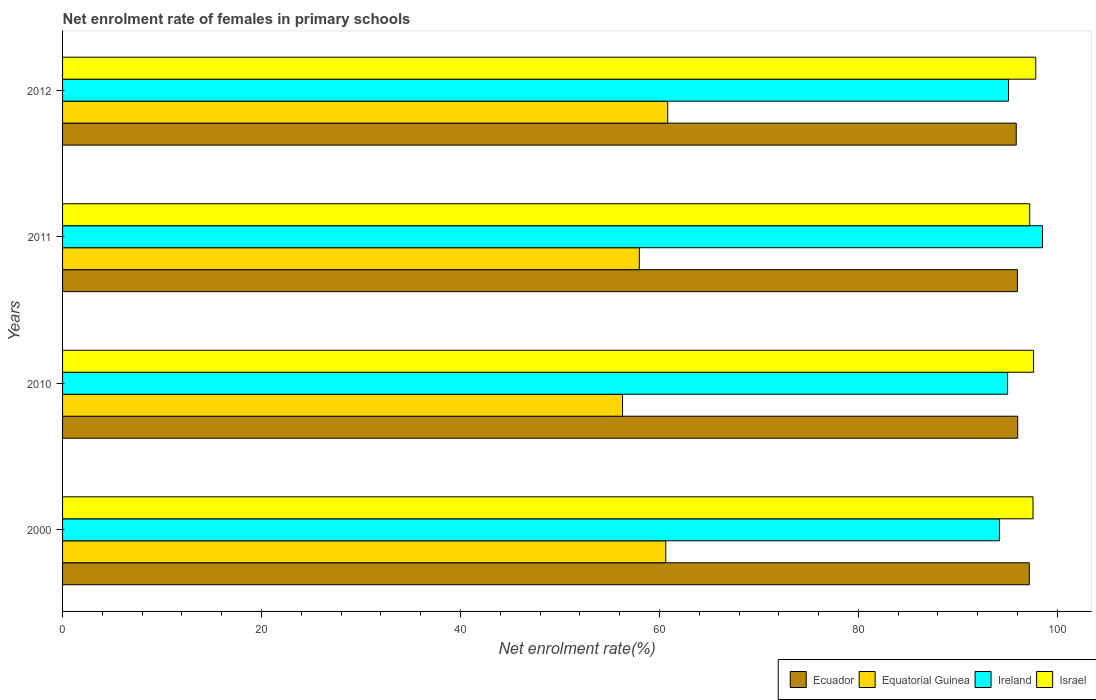How many different coloured bars are there?
Give a very brief answer. 4. Are the number of bars per tick equal to the number of legend labels?
Your answer should be very brief. Yes. How many bars are there on the 4th tick from the top?
Provide a short and direct response. 4. How many bars are there on the 4th tick from the bottom?
Your response must be concise. 4. In how many cases, is the number of bars for a given year not equal to the number of legend labels?
Your response must be concise. 0. What is the net enrolment rate of females in primary schools in Ecuador in 2000?
Provide a short and direct response. 97.18. Across all years, what is the maximum net enrolment rate of females in primary schools in Ireland?
Give a very brief answer. 98.51. Across all years, what is the minimum net enrolment rate of females in primary schools in Israel?
Offer a very short reply. 97.22. In which year was the net enrolment rate of females in primary schools in Equatorial Guinea maximum?
Your answer should be compact. 2012. What is the total net enrolment rate of females in primary schools in Equatorial Guinea in the graph?
Your answer should be very brief. 235.74. What is the difference between the net enrolment rate of females in primary schools in Israel in 2010 and that in 2011?
Keep it short and to the point. 0.39. What is the difference between the net enrolment rate of females in primary schools in Ireland in 2011 and the net enrolment rate of females in primary schools in Equatorial Guinea in 2000?
Your answer should be very brief. 37.87. What is the average net enrolment rate of females in primary schools in Equatorial Guinea per year?
Offer a terse response. 58.93. In the year 2011, what is the difference between the net enrolment rate of females in primary schools in Israel and net enrolment rate of females in primary schools in Ireland?
Offer a terse response. -1.28. In how many years, is the net enrolment rate of females in primary schools in Equatorial Guinea greater than 84 %?
Make the answer very short. 0. What is the ratio of the net enrolment rate of females in primary schools in Ecuador in 2000 to that in 2011?
Offer a terse response. 1.01. Is the net enrolment rate of females in primary schools in Israel in 2010 less than that in 2012?
Provide a succinct answer. Yes. Is the difference between the net enrolment rate of females in primary schools in Israel in 2000 and 2012 greater than the difference between the net enrolment rate of females in primary schools in Ireland in 2000 and 2012?
Provide a short and direct response. Yes. What is the difference between the highest and the second highest net enrolment rate of females in primary schools in Israel?
Make the answer very short. 0.22. What is the difference between the highest and the lowest net enrolment rate of females in primary schools in Israel?
Provide a short and direct response. 0.61. In how many years, is the net enrolment rate of females in primary schools in Equatorial Guinea greater than the average net enrolment rate of females in primary schools in Equatorial Guinea taken over all years?
Your answer should be compact. 2. Is the sum of the net enrolment rate of females in primary schools in Ireland in 2000 and 2010 greater than the maximum net enrolment rate of females in primary schools in Israel across all years?
Keep it short and to the point. Yes. What does the 2nd bar from the top in 2012 represents?
Ensure brevity in your answer.  Ireland. What does the 1st bar from the bottom in 2011 represents?
Offer a very short reply. Ecuador. Is it the case that in every year, the sum of the net enrolment rate of females in primary schools in Ireland and net enrolment rate of females in primary schools in Ecuador is greater than the net enrolment rate of females in primary schools in Equatorial Guinea?
Provide a succinct answer. Yes. How many bars are there?
Ensure brevity in your answer.  16. Does the graph contain grids?
Offer a terse response. No. Where does the legend appear in the graph?
Offer a terse response. Bottom right. What is the title of the graph?
Your answer should be very brief. Net enrolment rate of females in primary schools. Does "Indonesia" appear as one of the legend labels in the graph?
Your response must be concise. No. What is the label or title of the X-axis?
Your answer should be very brief. Net enrolment rate(%). What is the label or title of the Y-axis?
Keep it short and to the point. Years. What is the Net enrolment rate(%) of Ecuador in 2000?
Keep it short and to the point. 97.18. What is the Net enrolment rate(%) of Equatorial Guinea in 2000?
Offer a terse response. 60.64. What is the Net enrolment rate(%) in Ireland in 2000?
Your answer should be compact. 94.18. What is the Net enrolment rate(%) in Israel in 2000?
Your answer should be compact. 97.55. What is the Net enrolment rate(%) of Ecuador in 2010?
Your answer should be compact. 96.01. What is the Net enrolment rate(%) in Equatorial Guinea in 2010?
Ensure brevity in your answer.  56.29. What is the Net enrolment rate(%) in Ireland in 2010?
Offer a very short reply. 95. What is the Net enrolment rate(%) of Israel in 2010?
Your response must be concise. 97.61. What is the Net enrolment rate(%) in Ecuador in 2011?
Give a very brief answer. 95.98. What is the Net enrolment rate(%) of Equatorial Guinea in 2011?
Your answer should be very brief. 57.98. What is the Net enrolment rate(%) of Ireland in 2011?
Provide a succinct answer. 98.51. What is the Net enrolment rate(%) in Israel in 2011?
Offer a terse response. 97.22. What is the Net enrolment rate(%) of Ecuador in 2012?
Make the answer very short. 95.87. What is the Net enrolment rate(%) of Equatorial Guinea in 2012?
Your answer should be very brief. 60.83. What is the Net enrolment rate(%) of Ireland in 2012?
Keep it short and to the point. 95.09. What is the Net enrolment rate(%) of Israel in 2012?
Ensure brevity in your answer.  97.83. Across all years, what is the maximum Net enrolment rate(%) of Ecuador?
Provide a succinct answer. 97.18. Across all years, what is the maximum Net enrolment rate(%) in Equatorial Guinea?
Your answer should be very brief. 60.83. Across all years, what is the maximum Net enrolment rate(%) in Ireland?
Your answer should be compact. 98.51. Across all years, what is the maximum Net enrolment rate(%) of Israel?
Keep it short and to the point. 97.83. Across all years, what is the minimum Net enrolment rate(%) of Ecuador?
Your answer should be compact. 95.87. Across all years, what is the minimum Net enrolment rate(%) in Equatorial Guinea?
Offer a terse response. 56.29. Across all years, what is the minimum Net enrolment rate(%) of Ireland?
Provide a short and direct response. 94.18. Across all years, what is the minimum Net enrolment rate(%) in Israel?
Make the answer very short. 97.22. What is the total Net enrolment rate(%) in Ecuador in the graph?
Provide a succinct answer. 385.04. What is the total Net enrolment rate(%) in Equatorial Guinea in the graph?
Ensure brevity in your answer.  235.74. What is the total Net enrolment rate(%) in Ireland in the graph?
Provide a short and direct response. 382.77. What is the total Net enrolment rate(%) in Israel in the graph?
Provide a short and direct response. 390.21. What is the difference between the Net enrolment rate(%) in Ecuador in 2000 and that in 2010?
Give a very brief answer. 1.16. What is the difference between the Net enrolment rate(%) in Equatorial Guinea in 2000 and that in 2010?
Provide a short and direct response. 4.35. What is the difference between the Net enrolment rate(%) of Ireland in 2000 and that in 2010?
Offer a terse response. -0.82. What is the difference between the Net enrolment rate(%) in Israel in 2000 and that in 2010?
Offer a terse response. -0.05. What is the difference between the Net enrolment rate(%) of Ecuador in 2000 and that in 2011?
Offer a very short reply. 1.19. What is the difference between the Net enrolment rate(%) of Equatorial Guinea in 2000 and that in 2011?
Make the answer very short. 2.66. What is the difference between the Net enrolment rate(%) of Ireland in 2000 and that in 2011?
Your answer should be very brief. -4.33. What is the difference between the Net enrolment rate(%) of Israel in 2000 and that in 2011?
Your answer should be compact. 0.33. What is the difference between the Net enrolment rate(%) of Ecuador in 2000 and that in 2012?
Make the answer very short. 1.31. What is the difference between the Net enrolment rate(%) in Equatorial Guinea in 2000 and that in 2012?
Your answer should be very brief. -0.19. What is the difference between the Net enrolment rate(%) in Ireland in 2000 and that in 2012?
Give a very brief answer. -0.91. What is the difference between the Net enrolment rate(%) in Israel in 2000 and that in 2012?
Keep it short and to the point. -0.28. What is the difference between the Net enrolment rate(%) in Ecuador in 2010 and that in 2011?
Your response must be concise. 0.03. What is the difference between the Net enrolment rate(%) in Equatorial Guinea in 2010 and that in 2011?
Offer a very short reply. -1.69. What is the difference between the Net enrolment rate(%) of Ireland in 2010 and that in 2011?
Provide a succinct answer. -3.51. What is the difference between the Net enrolment rate(%) in Israel in 2010 and that in 2011?
Keep it short and to the point. 0.39. What is the difference between the Net enrolment rate(%) in Ecuador in 2010 and that in 2012?
Your response must be concise. 0.15. What is the difference between the Net enrolment rate(%) of Equatorial Guinea in 2010 and that in 2012?
Provide a succinct answer. -4.54. What is the difference between the Net enrolment rate(%) of Ireland in 2010 and that in 2012?
Give a very brief answer. -0.09. What is the difference between the Net enrolment rate(%) of Israel in 2010 and that in 2012?
Your response must be concise. -0.22. What is the difference between the Net enrolment rate(%) in Ecuador in 2011 and that in 2012?
Your answer should be compact. 0.12. What is the difference between the Net enrolment rate(%) of Equatorial Guinea in 2011 and that in 2012?
Keep it short and to the point. -2.85. What is the difference between the Net enrolment rate(%) in Ireland in 2011 and that in 2012?
Your answer should be compact. 3.41. What is the difference between the Net enrolment rate(%) of Israel in 2011 and that in 2012?
Ensure brevity in your answer.  -0.61. What is the difference between the Net enrolment rate(%) of Ecuador in 2000 and the Net enrolment rate(%) of Equatorial Guinea in 2010?
Make the answer very short. 40.88. What is the difference between the Net enrolment rate(%) in Ecuador in 2000 and the Net enrolment rate(%) in Ireland in 2010?
Offer a very short reply. 2.18. What is the difference between the Net enrolment rate(%) in Ecuador in 2000 and the Net enrolment rate(%) in Israel in 2010?
Give a very brief answer. -0.43. What is the difference between the Net enrolment rate(%) in Equatorial Guinea in 2000 and the Net enrolment rate(%) in Ireland in 2010?
Offer a terse response. -34.36. What is the difference between the Net enrolment rate(%) in Equatorial Guinea in 2000 and the Net enrolment rate(%) in Israel in 2010?
Offer a terse response. -36.97. What is the difference between the Net enrolment rate(%) of Ireland in 2000 and the Net enrolment rate(%) of Israel in 2010?
Provide a succinct answer. -3.43. What is the difference between the Net enrolment rate(%) in Ecuador in 2000 and the Net enrolment rate(%) in Equatorial Guinea in 2011?
Offer a very short reply. 39.2. What is the difference between the Net enrolment rate(%) in Ecuador in 2000 and the Net enrolment rate(%) in Ireland in 2011?
Keep it short and to the point. -1.33. What is the difference between the Net enrolment rate(%) of Ecuador in 2000 and the Net enrolment rate(%) of Israel in 2011?
Your answer should be compact. -0.05. What is the difference between the Net enrolment rate(%) in Equatorial Guinea in 2000 and the Net enrolment rate(%) in Ireland in 2011?
Your answer should be very brief. -37.87. What is the difference between the Net enrolment rate(%) of Equatorial Guinea in 2000 and the Net enrolment rate(%) of Israel in 2011?
Provide a short and direct response. -36.58. What is the difference between the Net enrolment rate(%) of Ireland in 2000 and the Net enrolment rate(%) of Israel in 2011?
Keep it short and to the point. -3.04. What is the difference between the Net enrolment rate(%) in Ecuador in 2000 and the Net enrolment rate(%) in Equatorial Guinea in 2012?
Provide a short and direct response. 36.35. What is the difference between the Net enrolment rate(%) of Ecuador in 2000 and the Net enrolment rate(%) of Ireland in 2012?
Your answer should be compact. 2.08. What is the difference between the Net enrolment rate(%) in Ecuador in 2000 and the Net enrolment rate(%) in Israel in 2012?
Your answer should be very brief. -0.65. What is the difference between the Net enrolment rate(%) of Equatorial Guinea in 2000 and the Net enrolment rate(%) of Ireland in 2012?
Give a very brief answer. -34.45. What is the difference between the Net enrolment rate(%) of Equatorial Guinea in 2000 and the Net enrolment rate(%) of Israel in 2012?
Provide a short and direct response. -37.19. What is the difference between the Net enrolment rate(%) in Ireland in 2000 and the Net enrolment rate(%) in Israel in 2012?
Offer a terse response. -3.65. What is the difference between the Net enrolment rate(%) of Ecuador in 2010 and the Net enrolment rate(%) of Equatorial Guinea in 2011?
Your answer should be very brief. 38.04. What is the difference between the Net enrolment rate(%) in Ecuador in 2010 and the Net enrolment rate(%) in Ireland in 2011?
Ensure brevity in your answer.  -2.49. What is the difference between the Net enrolment rate(%) in Ecuador in 2010 and the Net enrolment rate(%) in Israel in 2011?
Make the answer very short. -1.21. What is the difference between the Net enrolment rate(%) in Equatorial Guinea in 2010 and the Net enrolment rate(%) in Ireland in 2011?
Your response must be concise. -42.21. What is the difference between the Net enrolment rate(%) in Equatorial Guinea in 2010 and the Net enrolment rate(%) in Israel in 2011?
Ensure brevity in your answer.  -40.93. What is the difference between the Net enrolment rate(%) of Ireland in 2010 and the Net enrolment rate(%) of Israel in 2011?
Ensure brevity in your answer.  -2.22. What is the difference between the Net enrolment rate(%) in Ecuador in 2010 and the Net enrolment rate(%) in Equatorial Guinea in 2012?
Your answer should be very brief. 35.18. What is the difference between the Net enrolment rate(%) in Ecuador in 2010 and the Net enrolment rate(%) in Ireland in 2012?
Your answer should be compact. 0.92. What is the difference between the Net enrolment rate(%) in Ecuador in 2010 and the Net enrolment rate(%) in Israel in 2012?
Your response must be concise. -1.81. What is the difference between the Net enrolment rate(%) of Equatorial Guinea in 2010 and the Net enrolment rate(%) of Ireland in 2012?
Your response must be concise. -38.8. What is the difference between the Net enrolment rate(%) in Equatorial Guinea in 2010 and the Net enrolment rate(%) in Israel in 2012?
Keep it short and to the point. -41.54. What is the difference between the Net enrolment rate(%) of Ireland in 2010 and the Net enrolment rate(%) of Israel in 2012?
Offer a very short reply. -2.83. What is the difference between the Net enrolment rate(%) of Ecuador in 2011 and the Net enrolment rate(%) of Equatorial Guinea in 2012?
Give a very brief answer. 35.15. What is the difference between the Net enrolment rate(%) of Ecuador in 2011 and the Net enrolment rate(%) of Ireland in 2012?
Your response must be concise. 0.89. What is the difference between the Net enrolment rate(%) of Ecuador in 2011 and the Net enrolment rate(%) of Israel in 2012?
Offer a terse response. -1.85. What is the difference between the Net enrolment rate(%) in Equatorial Guinea in 2011 and the Net enrolment rate(%) in Ireland in 2012?
Ensure brevity in your answer.  -37.11. What is the difference between the Net enrolment rate(%) of Equatorial Guinea in 2011 and the Net enrolment rate(%) of Israel in 2012?
Offer a very short reply. -39.85. What is the difference between the Net enrolment rate(%) in Ireland in 2011 and the Net enrolment rate(%) in Israel in 2012?
Your answer should be compact. 0.68. What is the average Net enrolment rate(%) of Ecuador per year?
Make the answer very short. 96.26. What is the average Net enrolment rate(%) of Equatorial Guinea per year?
Provide a succinct answer. 58.93. What is the average Net enrolment rate(%) in Ireland per year?
Make the answer very short. 95.69. What is the average Net enrolment rate(%) of Israel per year?
Provide a short and direct response. 97.55. In the year 2000, what is the difference between the Net enrolment rate(%) in Ecuador and Net enrolment rate(%) in Equatorial Guinea?
Your answer should be compact. 36.54. In the year 2000, what is the difference between the Net enrolment rate(%) of Ecuador and Net enrolment rate(%) of Ireland?
Keep it short and to the point. 3. In the year 2000, what is the difference between the Net enrolment rate(%) of Ecuador and Net enrolment rate(%) of Israel?
Your answer should be compact. -0.38. In the year 2000, what is the difference between the Net enrolment rate(%) of Equatorial Guinea and Net enrolment rate(%) of Ireland?
Offer a very short reply. -33.54. In the year 2000, what is the difference between the Net enrolment rate(%) in Equatorial Guinea and Net enrolment rate(%) in Israel?
Make the answer very short. -36.92. In the year 2000, what is the difference between the Net enrolment rate(%) of Ireland and Net enrolment rate(%) of Israel?
Ensure brevity in your answer.  -3.38. In the year 2010, what is the difference between the Net enrolment rate(%) of Ecuador and Net enrolment rate(%) of Equatorial Guinea?
Keep it short and to the point. 39.72. In the year 2010, what is the difference between the Net enrolment rate(%) of Ecuador and Net enrolment rate(%) of Ireland?
Provide a succinct answer. 1.02. In the year 2010, what is the difference between the Net enrolment rate(%) of Ecuador and Net enrolment rate(%) of Israel?
Make the answer very short. -1.59. In the year 2010, what is the difference between the Net enrolment rate(%) in Equatorial Guinea and Net enrolment rate(%) in Ireland?
Ensure brevity in your answer.  -38.71. In the year 2010, what is the difference between the Net enrolment rate(%) of Equatorial Guinea and Net enrolment rate(%) of Israel?
Offer a very short reply. -41.32. In the year 2010, what is the difference between the Net enrolment rate(%) of Ireland and Net enrolment rate(%) of Israel?
Keep it short and to the point. -2.61. In the year 2011, what is the difference between the Net enrolment rate(%) in Ecuador and Net enrolment rate(%) in Equatorial Guinea?
Keep it short and to the point. 38.01. In the year 2011, what is the difference between the Net enrolment rate(%) in Ecuador and Net enrolment rate(%) in Ireland?
Make the answer very short. -2.52. In the year 2011, what is the difference between the Net enrolment rate(%) in Ecuador and Net enrolment rate(%) in Israel?
Provide a succinct answer. -1.24. In the year 2011, what is the difference between the Net enrolment rate(%) of Equatorial Guinea and Net enrolment rate(%) of Ireland?
Your response must be concise. -40.53. In the year 2011, what is the difference between the Net enrolment rate(%) in Equatorial Guinea and Net enrolment rate(%) in Israel?
Give a very brief answer. -39.24. In the year 2011, what is the difference between the Net enrolment rate(%) of Ireland and Net enrolment rate(%) of Israel?
Provide a short and direct response. 1.28. In the year 2012, what is the difference between the Net enrolment rate(%) in Ecuador and Net enrolment rate(%) in Equatorial Guinea?
Your answer should be compact. 35.04. In the year 2012, what is the difference between the Net enrolment rate(%) in Ecuador and Net enrolment rate(%) in Ireland?
Provide a short and direct response. 0.78. In the year 2012, what is the difference between the Net enrolment rate(%) of Ecuador and Net enrolment rate(%) of Israel?
Keep it short and to the point. -1.96. In the year 2012, what is the difference between the Net enrolment rate(%) in Equatorial Guinea and Net enrolment rate(%) in Ireland?
Your answer should be compact. -34.26. In the year 2012, what is the difference between the Net enrolment rate(%) of Equatorial Guinea and Net enrolment rate(%) of Israel?
Make the answer very short. -37. In the year 2012, what is the difference between the Net enrolment rate(%) of Ireland and Net enrolment rate(%) of Israel?
Provide a short and direct response. -2.74. What is the ratio of the Net enrolment rate(%) in Ecuador in 2000 to that in 2010?
Make the answer very short. 1.01. What is the ratio of the Net enrolment rate(%) of Equatorial Guinea in 2000 to that in 2010?
Your answer should be compact. 1.08. What is the ratio of the Net enrolment rate(%) of Ecuador in 2000 to that in 2011?
Your answer should be compact. 1.01. What is the ratio of the Net enrolment rate(%) in Equatorial Guinea in 2000 to that in 2011?
Offer a very short reply. 1.05. What is the ratio of the Net enrolment rate(%) of Ireland in 2000 to that in 2011?
Your answer should be very brief. 0.96. What is the ratio of the Net enrolment rate(%) of Ecuador in 2000 to that in 2012?
Offer a very short reply. 1.01. What is the ratio of the Net enrolment rate(%) of Equatorial Guinea in 2000 to that in 2012?
Provide a short and direct response. 1. What is the ratio of the Net enrolment rate(%) in Equatorial Guinea in 2010 to that in 2011?
Provide a succinct answer. 0.97. What is the ratio of the Net enrolment rate(%) of Ireland in 2010 to that in 2011?
Offer a terse response. 0.96. What is the ratio of the Net enrolment rate(%) of Israel in 2010 to that in 2011?
Your response must be concise. 1. What is the ratio of the Net enrolment rate(%) of Ecuador in 2010 to that in 2012?
Provide a short and direct response. 1. What is the ratio of the Net enrolment rate(%) in Equatorial Guinea in 2010 to that in 2012?
Ensure brevity in your answer.  0.93. What is the ratio of the Net enrolment rate(%) in Ireland in 2010 to that in 2012?
Your response must be concise. 1. What is the ratio of the Net enrolment rate(%) of Ecuador in 2011 to that in 2012?
Make the answer very short. 1. What is the ratio of the Net enrolment rate(%) in Equatorial Guinea in 2011 to that in 2012?
Provide a short and direct response. 0.95. What is the ratio of the Net enrolment rate(%) of Ireland in 2011 to that in 2012?
Provide a succinct answer. 1.04. What is the difference between the highest and the second highest Net enrolment rate(%) of Ecuador?
Your answer should be compact. 1.16. What is the difference between the highest and the second highest Net enrolment rate(%) in Equatorial Guinea?
Offer a terse response. 0.19. What is the difference between the highest and the second highest Net enrolment rate(%) in Ireland?
Keep it short and to the point. 3.41. What is the difference between the highest and the second highest Net enrolment rate(%) of Israel?
Your answer should be compact. 0.22. What is the difference between the highest and the lowest Net enrolment rate(%) of Ecuador?
Provide a short and direct response. 1.31. What is the difference between the highest and the lowest Net enrolment rate(%) in Equatorial Guinea?
Offer a terse response. 4.54. What is the difference between the highest and the lowest Net enrolment rate(%) in Ireland?
Give a very brief answer. 4.33. What is the difference between the highest and the lowest Net enrolment rate(%) of Israel?
Offer a terse response. 0.61. 